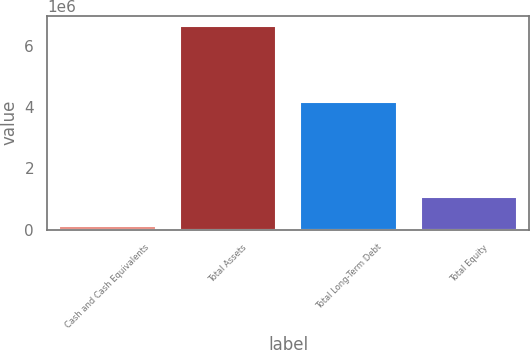Convert chart. <chart><loc_0><loc_0><loc_500><loc_500><bar_chart><fcel>Cash and Cash Equivalents<fcel>Total Assets<fcel>Total Long-Term Debt<fcel>Total Equity<nl><fcel>120526<fcel>6.653e+06<fcel>4.17172e+06<fcel>1.05173e+06<nl></chart> 